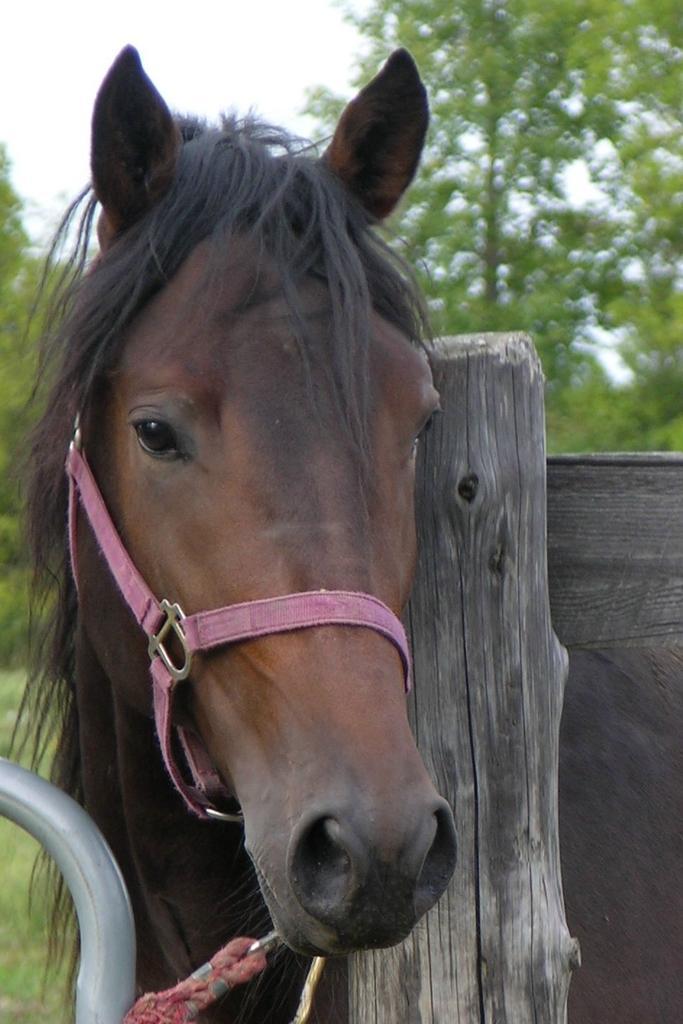How would you summarize this image in a sentence or two? In this image we can see a horse and beside we can see a wooden log which looks like a fence and in the background, we can see some trees. 